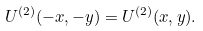<formula> <loc_0><loc_0><loc_500><loc_500>U ^ { ( 2 ) } ( - x , - y ) = U ^ { ( 2 ) } ( x , y ) .</formula> 